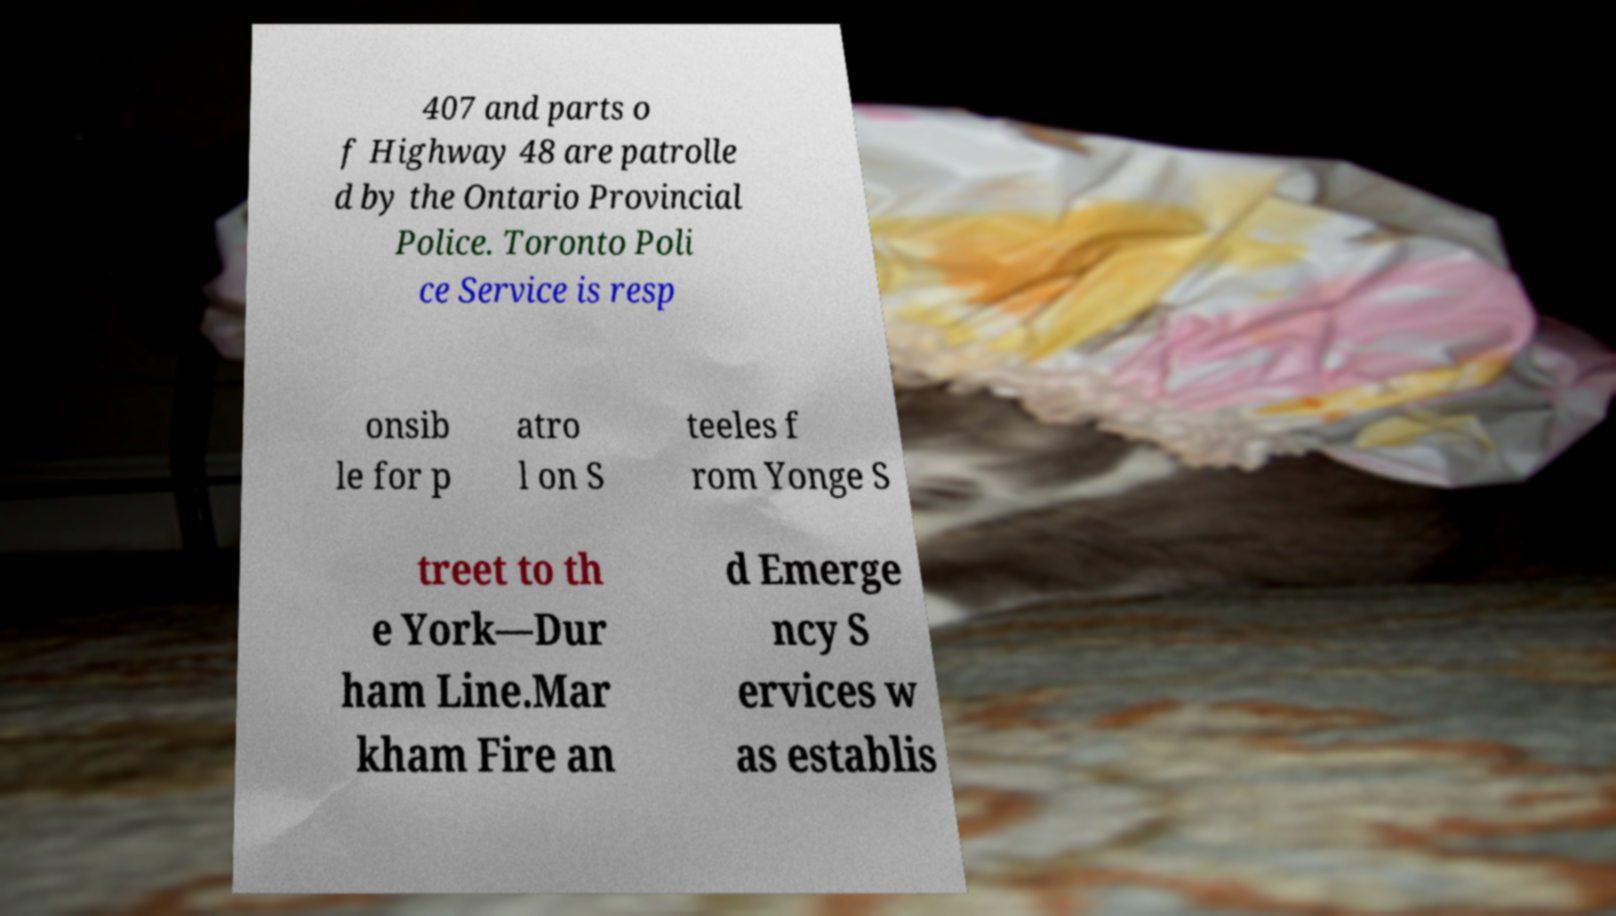There's text embedded in this image that I need extracted. Can you transcribe it verbatim? 407 and parts o f Highway 48 are patrolle d by the Ontario Provincial Police. Toronto Poli ce Service is resp onsib le for p atro l on S teeles f rom Yonge S treet to th e York—Dur ham Line.Mar kham Fire an d Emerge ncy S ervices w as establis 